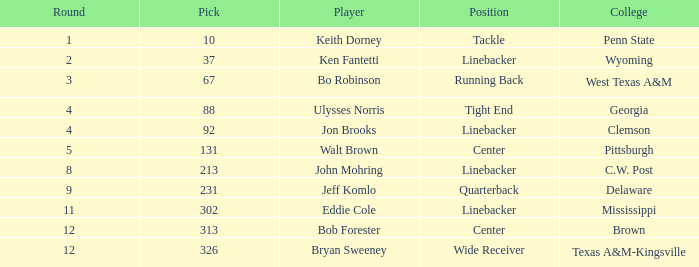What is the college pick for 213? C.W. Post. 